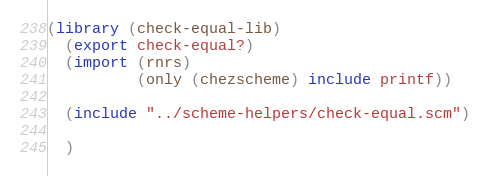<code> <loc_0><loc_0><loc_500><loc_500><_Scheme_>(library (check-equal-lib)
  (export check-equal?)
  (import (rnrs)
          (only (chezscheme) include printf))

  (include "../scheme-helpers/check-equal.scm")
  
  )
</code> 